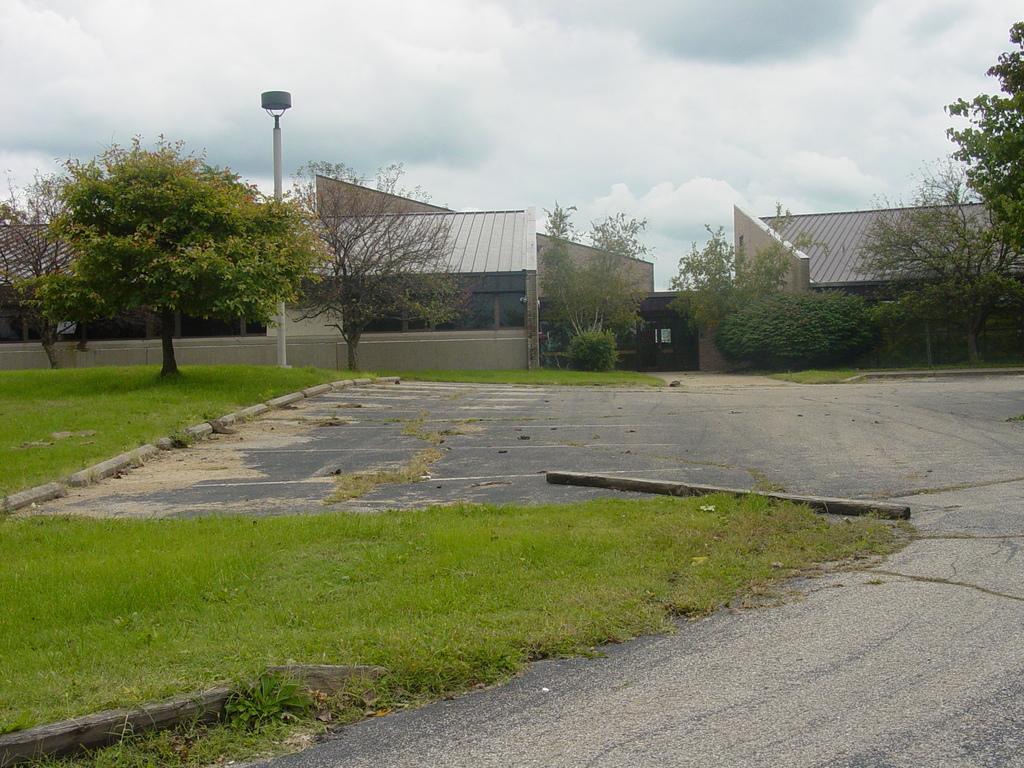Please provide a concise description of this image. This image is clicked on the road. At the bottom, there is a road and green grass. In the background, there are houses along with trees. At the top, there are clouds in the sky. 